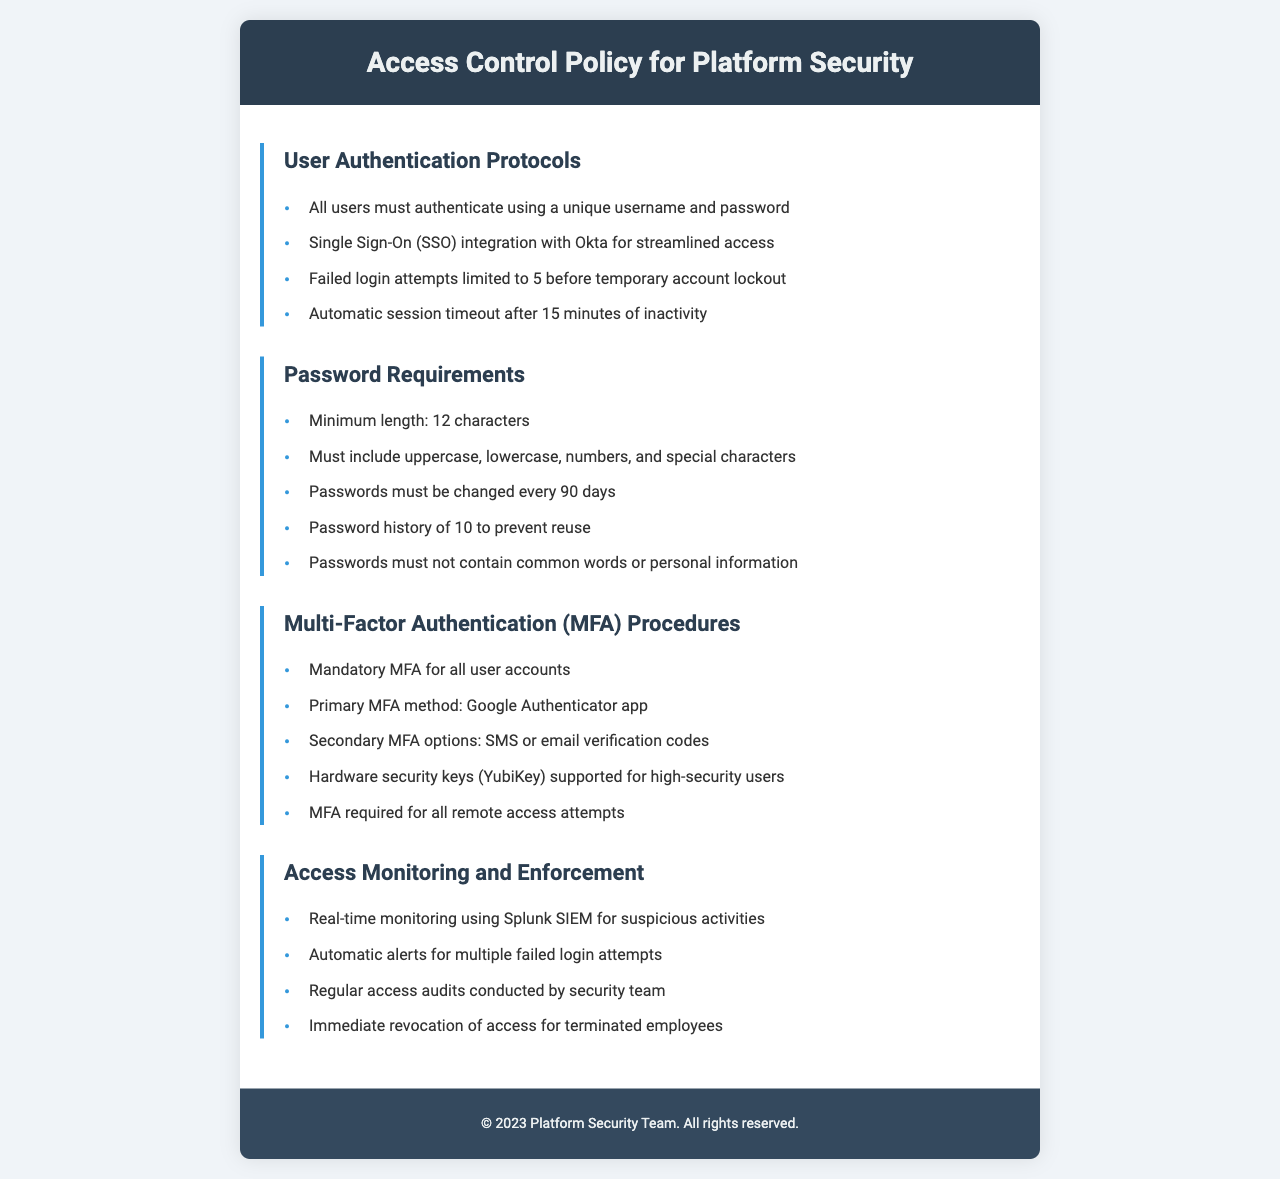What is the unique requirement for user authentication? The document states that all users must authenticate using a unique username and password.
Answer: unique username and password How many failed login attempts result in a temporary account lockout? The policy specifies that failed login attempts are limited to 5 before the account is temporarily locked out.
Answer: 5 What is the minimum password length specified? The policy document mentions that the minimum length for passwords is 12 characters.
Answer: 12 characters How often must passwords be changed? According to the document, passwords must be changed every 90 days.
Answer: 90 days What is the primary method for multi-factor authentication? The policy indicates that the primary MFA method used is the Google Authenticator app.
Answer: Google Authenticator app What are the secondary MFA options mentioned? The secondary MFA options include SMS or email verification codes.
Answer: SMS or email verification codes What is required for all remote access attempts? The document states that MFA is required for all remote access attempts.
Answer: MFA How long does a session remain active before timeout? The policy specifies that there is an automatic session timeout after 15 minutes of inactivity.
Answer: 15 minutes What tool is used for real-time access monitoring? The document mentions the use of Splunk SIEM for real-time monitoring of suspicious activities.
Answer: Splunk SIEM 